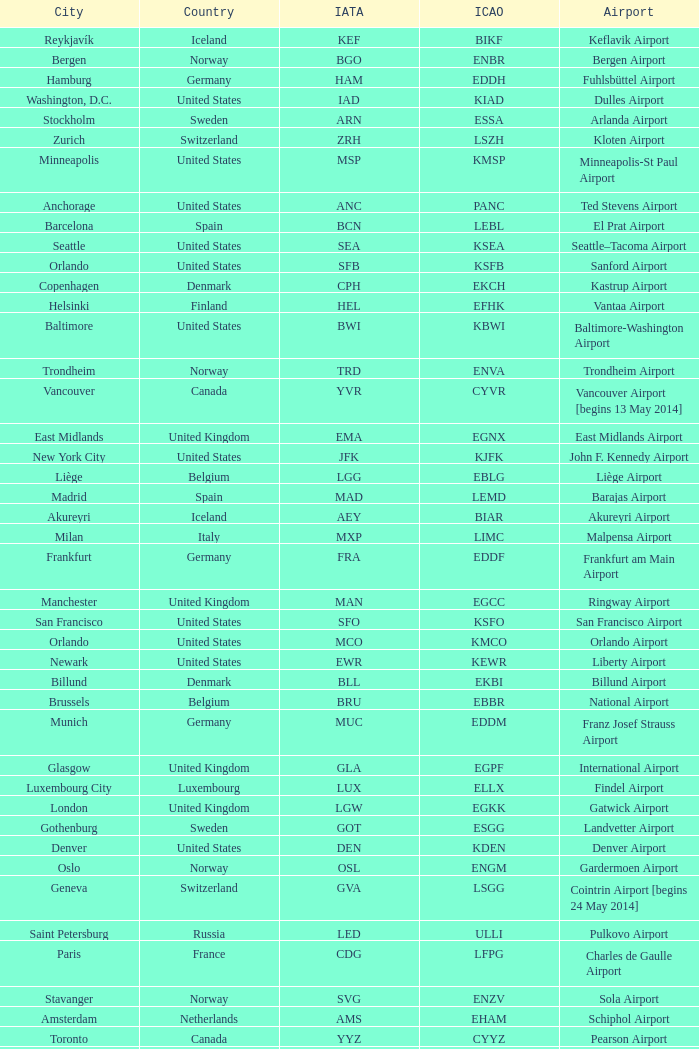What is the Airport with a ICAO of EDDH? Fuhlsbüttel Airport. 